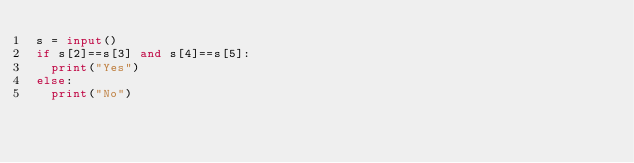<code> <loc_0><loc_0><loc_500><loc_500><_Python_>s = input()
if s[2]==s[3] and s[4]==s[5]:
  print("Yes")
else:
  print("No")
</code> 